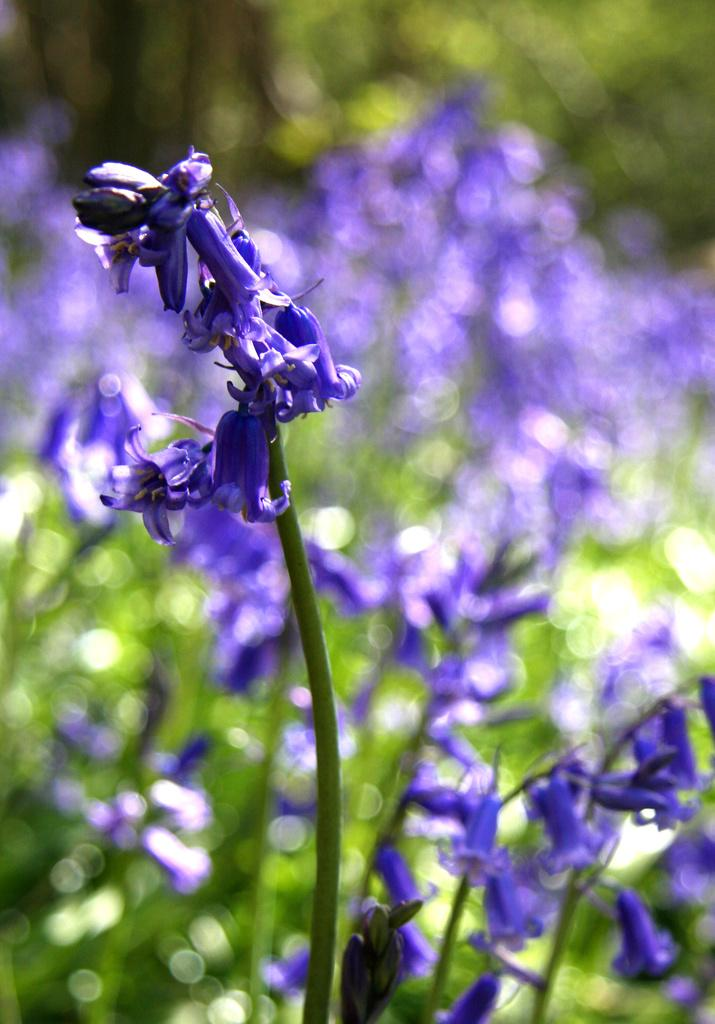What type of plants are present in the image? There are plants with flowers in the image. What color are the flowers on the plants? The flowers are violet in color. Are there any other plants or flowers visible in the image? Yes, there are other plants and flowers visible in the background, but their clarity is not mentioned. What type of pear is being judged by the relation in the image? There is no pear, judge, or relation present in the image. 